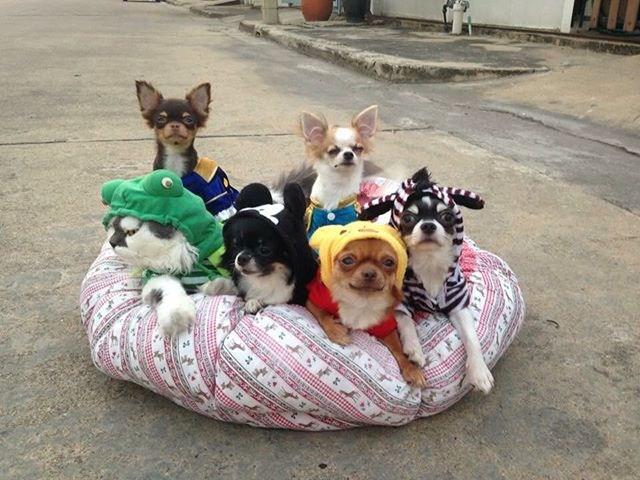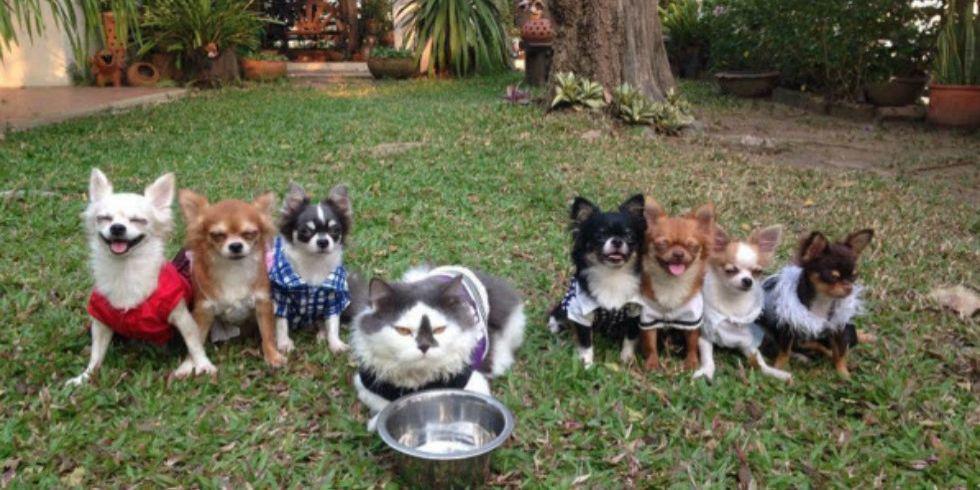The first image is the image on the left, the second image is the image on the right. Examine the images to the left and right. Is the description "There s exactly one cat that is not wearing any clothing." accurate? Answer yes or no. No. The first image is the image on the left, the second image is the image on the right. Assess this claim about the two images: "Multiple small dogs and one cat pose on a pet bed outdoors on pavement in one image.". Correct or not? Answer yes or no. Yes. 